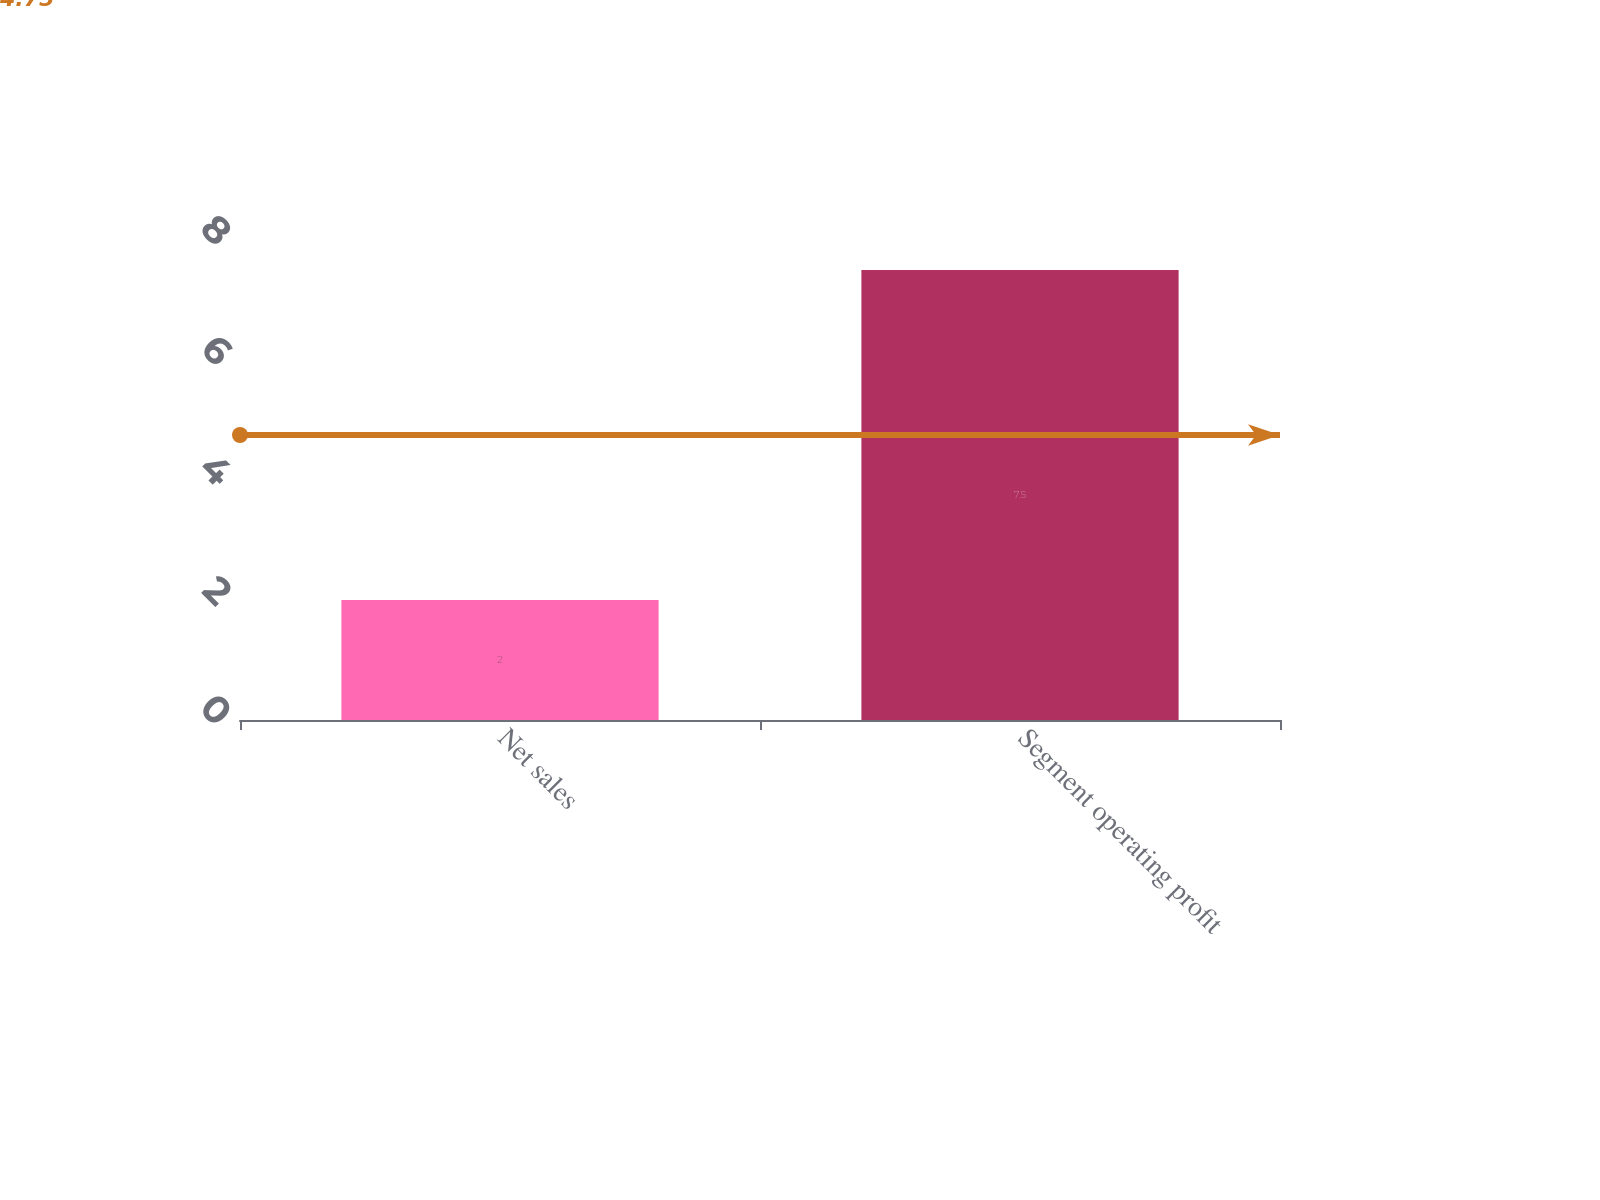Convert chart to OTSL. <chart><loc_0><loc_0><loc_500><loc_500><bar_chart><fcel>Net sales<fcel>Segment operating profit<nl><fcel>2<fcel>7.5<nl></chart> 